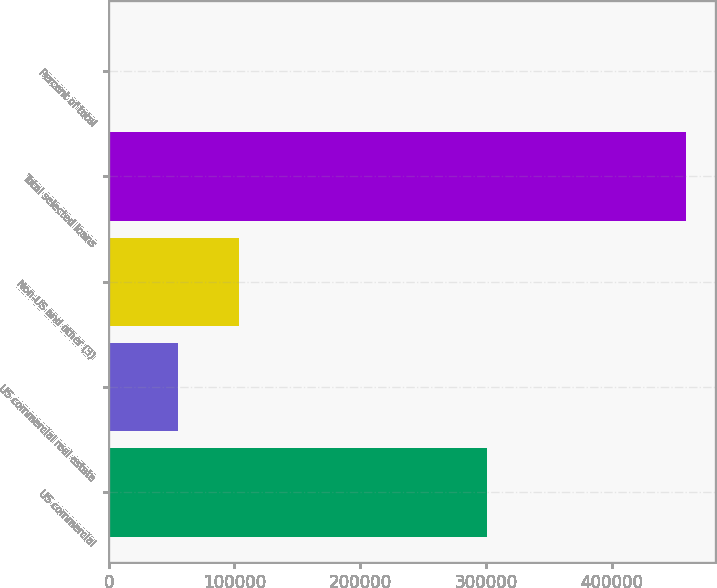<chart> <loc_0><loc_0><loc_500><loc_500><bar_chart><fcel>US commercial<fcel>US commercial real estate<fcel>Non-US and other (3)<fcel>Total selected loans<fcel>Percent of total<nl><fcel>301112<fcel>54761<fcel>103484<fcel>459357<fcel>100<nl></chart> 